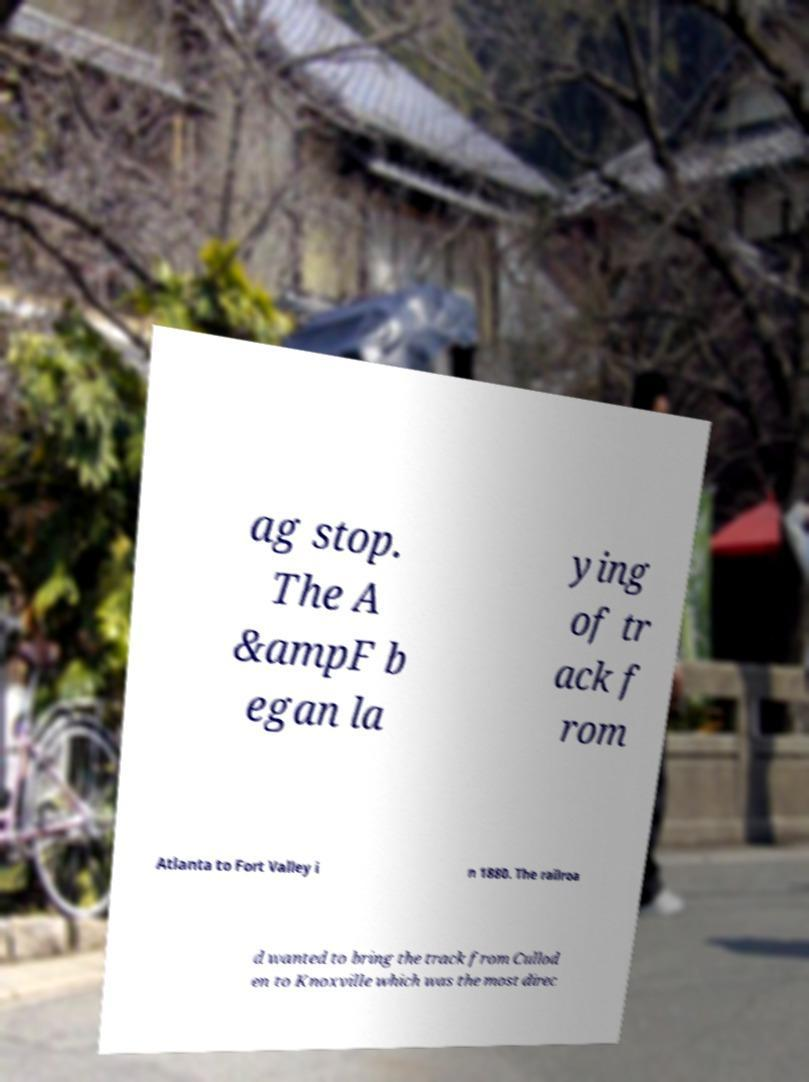Could you extract and type out the text from this image? ag stop. The A &ampF b egan la ying of tr ack f rom Atlanta to Fort Valley i n 1880. The railroa d wanted to bring the track from Cullod en to Knoxville which was the most direc 